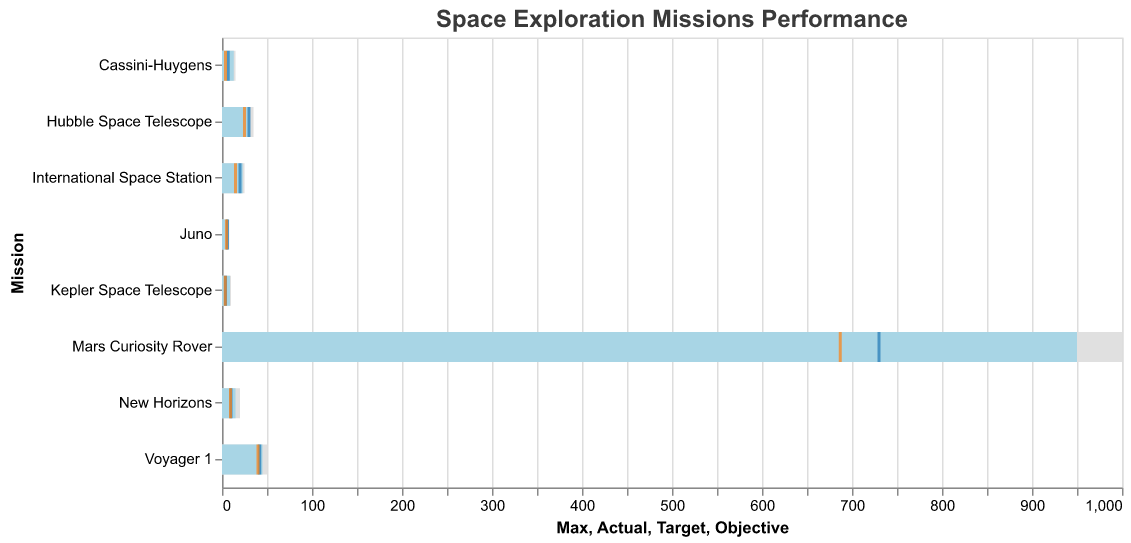What are the objectives of the Mars Curiosity Rover and Voyager 1 missions? The objectives are shown by the orange tick marks on the bullet chart. For the Mars Curiosity Rover, the objective is 687 units, and for Voyager 1, it is 40 units.
Answer: 687, 40 Which mission surpassed its target by the widest margin? The difference between the actual and target values can be calculated for each mission. Mars Curiosity Rover surpassed the target by 950 - 730 = 220 units; Hubble Space Telescope by 31 - 30 = 1 unit; Voyager 1 by 45 - 42 = 3 units; Cassini-Huygens by 13 - 7 = 6 units; New Horizons by 15 - 10 = 5 units; Kepler Space Telescope by 9 - 4 = 5 units; International Space Station by 23 - 20 = 3 units; Juno by 7 - 6 = 1 unit. The Mars Curiosity Rover has the widest margin.
Answer: Mars Curiosity Rover Did the International Space Station reach its maximum value? The actual value bar for the International Space Station is at 23 units, while its maximum value bar is at 25 units. Since 23 is less than 25, it did not reach the maximum value.
Answer: No Which missions met or exceeded their targets? By looking at the tick marks for the targets and comparing them with the bars for actual values, we see that the Mars Curiosity Rover (950 >= 730), Hubble Space Telescope (31 >= 30), Voyager 1 (45 >= 42), Cassini-Huygens (13 >= 7), New Horizons (15 >= 10), Kepler Space Telescope (9 >= 4), International Space Station (23 >= 20), and Juno (7 >= 6) all met or exceeded their targets.
Answer: All missions What is the difference between the actual and max values of the Hubble Space Telescope mission? The actual value is 31 and the max value is 35. The difference is calculated as 35 - 31.
Answer: 4 Which mission had the smallest difference between its actual and maximum values? The differences can be calculated as follows: Mars Curiosity Rover (1000 - 950 = 50), Hubble Space Telescope (35 - 31 = 4), Voyager 1 (50 - 45 = 5), Cassini-Huygens (15 - 13 = 2), New Horizons (20 - 15 = 5), Kepler Space Telescope (10 - 9 = 1), International Space Station (25 - 23 = 2), Juno (8 - 7 = 1). The Kepler Space Telescope and Juno both had the smallest difference of 1.
Answer: Kepler Space Telescope, Juno Which mission had the highest actual value? By observing the bars representing the actual values, we can see that the Mars Curiosity Rover had the highest actual value of 950 units.
Answer: Mars Curiosity Rover 